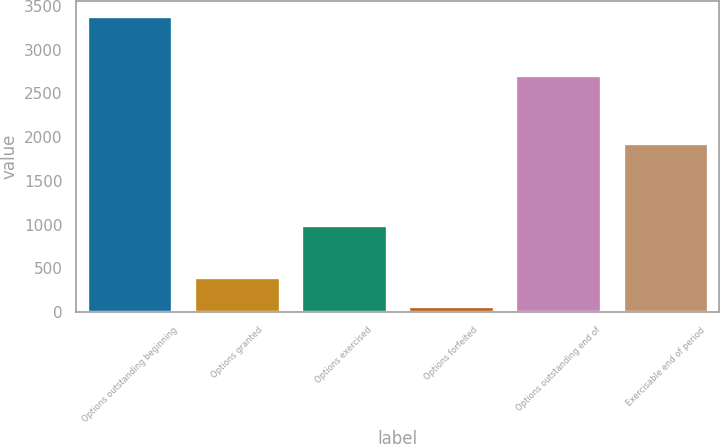Convert chart. <chart><loc_0><loc_0><loc_500><loc_500><bar_chart><fcel>Options outstanding beginning<fcel>Options granted<fcel>Options exercised<fcel>Options forfeited<fcel>Options outstanding end of<fcel>Exercisable end of period<nl><fcel>3391<fcel>404.8<fcel>1002<fcel>73<fcel>2717<fcel>1938<nl></chart> 